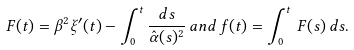<formula> <loc_0><loc_0><loc_500><loc_500>F ( t ) = \beta ^ { 2 } \xi ^ { \prime } ( t ) - \int _ { 0 } ^ { t } \frac { d s } { \hat { \alpha } ( s ) ^ { 2 } } \, a n d \, f ( t ) = \int _ { 0 } ^ { t } \, F ( s ) \, d s .</formula> 